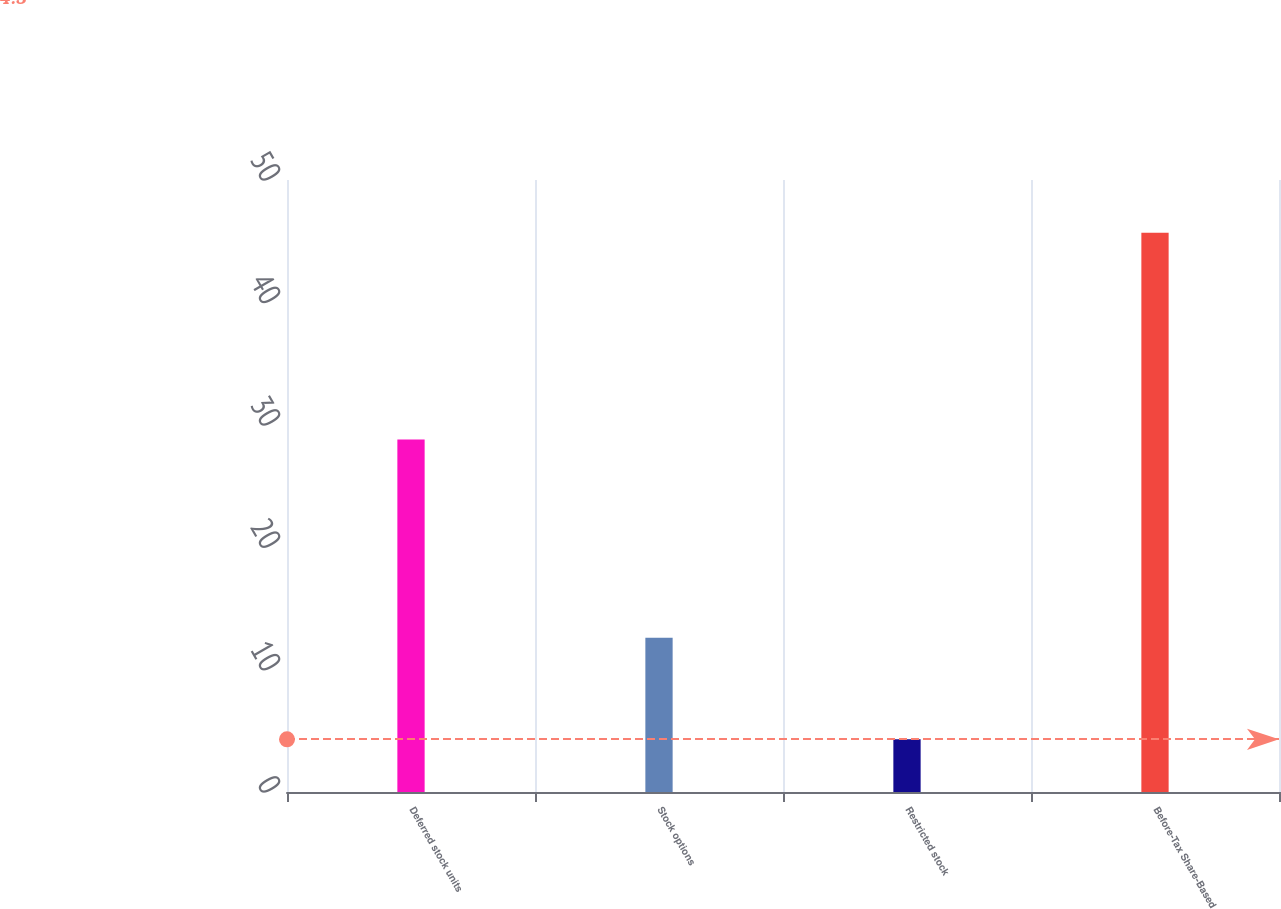Convert chart to OTSL. <chart><loc_0><loc_0><loc_500><loc_500><bar_chart><fcel>Deferred stock units<fcel>Stock options<fcel>Restricted stock<fcel>Before-Tax Share-Based<nl><fcel>28.8<fcel>12.6<fcel>4.3<fcel>45.7<nl></chart> 